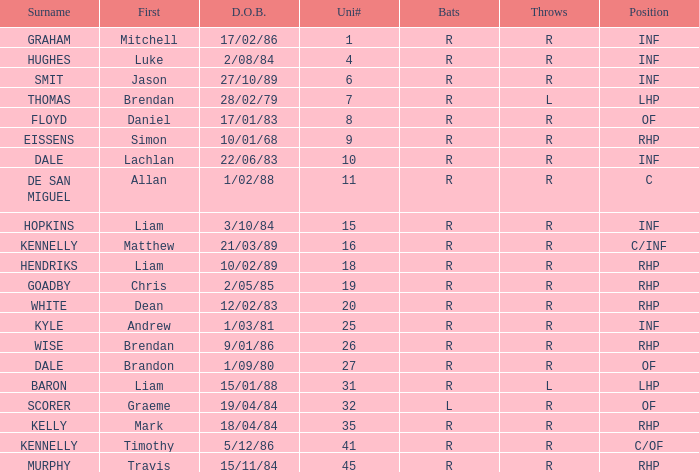Which hitter has a uni# 31? R. 